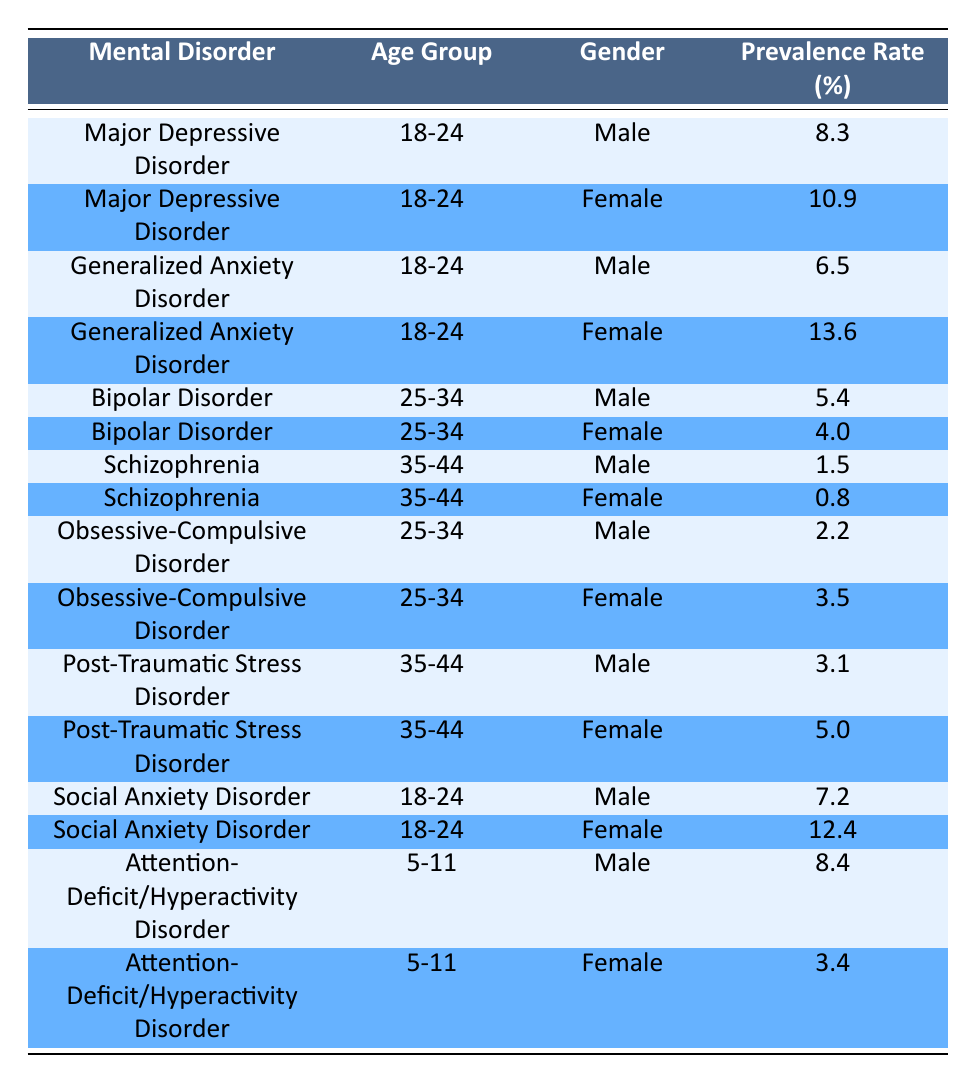What is the prevalence rate of Major Depressive Disorder among females aged 18-24? The table shows that for the disorder Major Depressive Disorder in the age group 18-24, the gender female has a prevalence rate of 10.9%.
Answer: 10.9 What is the prevalence rate of Schizophrenia for males aged 35-44? Looking at the row for Schizophrenia in the age group 35-44 for males, the prevalence rate is 1.5%.
Answer: 1.5 Which age group has the highest prevalence rate of Generalized Anxiety Disorder for females? The relevant rows for Generalized Anxiety Disorder show that the age group 18-24 has a prevalence rate of 13.6% for females, which is higher compared to any other age group listed.
Answer: 18-24 Is the prevalence rate of Attention-Deficit/Hyperactivity Disorder higher in males or females aged 5-11? The table shows that the prevalence rate for males aged 5-11 is 8.4% and for females it is 3.4%. Since 8.4 is greater than 3.4, the prevalence rate is higher in males.
Answer: Yes What is the combined prevalence rate of Social Anxiety Disorder for both genders in the age group 18-24? The prevalence rates for Social Anxiety Disorder in the age group 18-24 are 7.2% for males and 12.4% for females. Adding these together gives 7.2 + 12.4 = 19.6%.
Answer: 19.6 Which disorder has the highest prevalence rate for males aged 25-34? Among the disorders listed for males aged 25-34, Bipolar Disorder has a prevalence rate of 5.4%, while Obsessive-Compulsive Disorder has 2.2%. Thus, Bipolar Disorder has the highest rate in this group.
Answer: Bipolar Disorder Is the prevalence of Post-Traumatic Stress Disorder in females aged 35-44 greater than that in males? Post-Traumatic Stress Disorder has a prevalence rate of 5.0% for females and 3.1% for males. Since 5.0 is greater than 3.1, the assertion is true.
Answer: Yes What is the average prevalence rate of Obsessive-Compulsive Disorder across both males and females aged 25-34? Males have a prevalence rate of 2.2% and females have 3.5% for Obsessive-Compulsive Disorder in the age group 25-34. The average is computed as (2.2 + 3.5) / 2 = 2.85%.
Answer: 2.85 Which mental disorder has the lowest prevalence rate among females in the 35-44 age group? Looking at the age group 35-44 for females, Schizophrenia has 0.8%, which is lower than the 5.0% of Post-Traumatic Stress Disorder. Thus, Schizophrenia has the lowest prevalence rate in this category.
Answer: Schizophrenia 